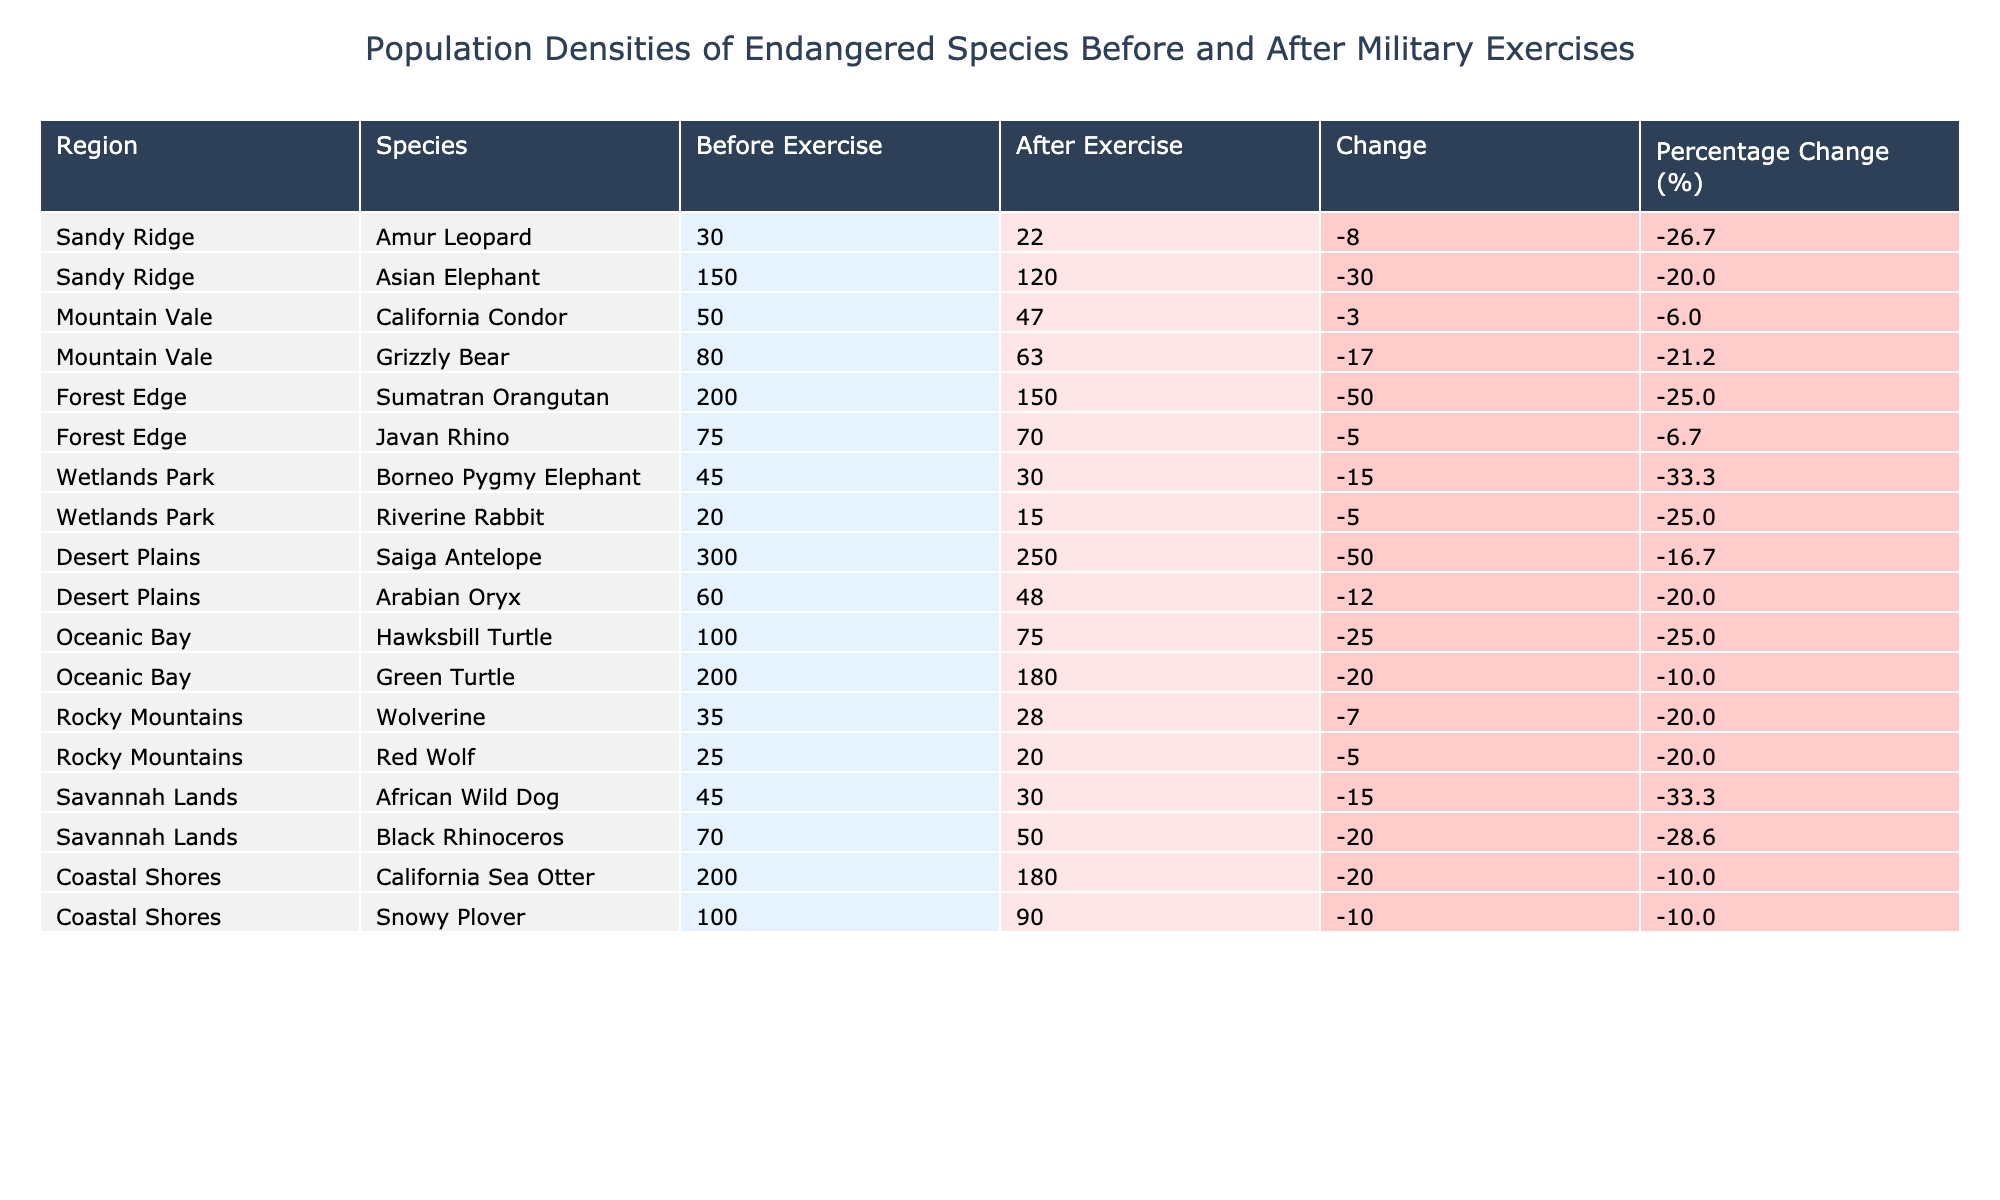What is the population of Amur Leopards before the military exercise? The table shows that the population of Amur Leopards in Sandy Ridge before the military exercise was 30.
Answer: 30 What is the change in population for the Asian Elephant after the military exercise? The change in population is calculated by subtracting the after exercise population (120) from the before exercise population (150), resulting in a change of -30.
Answer: -30 How many total Saiga Antelopes were there before the military exercise? The table lists 300 Saiga Antelopes before the military exercise, as shown in the Desert Plains row.
Answer: 300 Did the population of the Riverine Rabbit increase or decrease after the military exercise? The population of Riverine Rabbits decreased from 20 to 15, indicating a decline.
Answer: Decreased What is the total percentage change in population for the Sumatran Orangutan? The percentage change is calculated as ((150 - 200) / 200) * 100 = -25%, indicating a decrease of 25%.
Answer: -25% Which species experienced the highest reduction in population and by how much? The species with the highest reduction is the Saiga Antelope, which decreased by 50 (from 300 to 250).
Answer: Saiga Antelope, 50 What is the average population change for species in the Forest Edge region? The changes for Sumatran Orangutan (-50) and Javan Rhino (-5), average would be (-50 + -5) / 2 = -27.5.
Answer: -27.5 How many species had a population decrease greater than 20? By examining the table, we can see that 6 species had a decrease greater than 20: Amur Leopard, Asian Elephant, Grizzly Bear, Sumatran Orangutan, Saiga Antelope, and African Wild Dog.
Answer: 6 What is the total population of endangered species after the military exercises in Coastal Shores? The populations of California Sea Otter (180) and Snowy Plover (90) total to 180 + 90 = 270.
Answer: 270 Which region shows the smallest percentage change in population for any species? Mountain Vale shows the smallest percentage change with the California Condor, which decreased by 6% ((47-50)/50*100).
Answer: Mountain Vale, 6% 